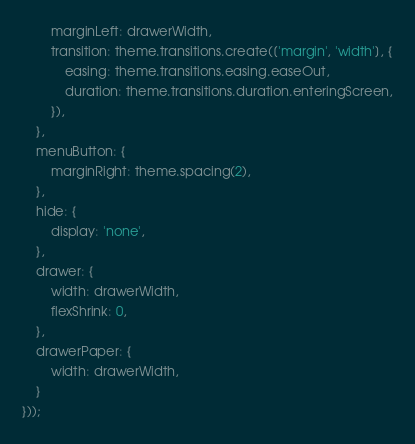Convert code to text. <code><loc_0><loc_0><loc_500><loc_500><_JavaScript_>        marginLeft: drawerWidth,
        transition: theme.transitions.create(['margin', 'width'], {
            easing: theme.transitions.easing.easeOut,
            duration: theme.transitions.duration.enteringScreen,
        }),
    },
    menuButton: {
        marginRight: theme.spacing(2),
    },
    hide: {
        display: 'none',
    },
    drawer: {
        width: drawerWidth,
        flexShrink: 0,
    },
    drawerPaper: {
        width: drawerWidth,
    }
}));</code> 